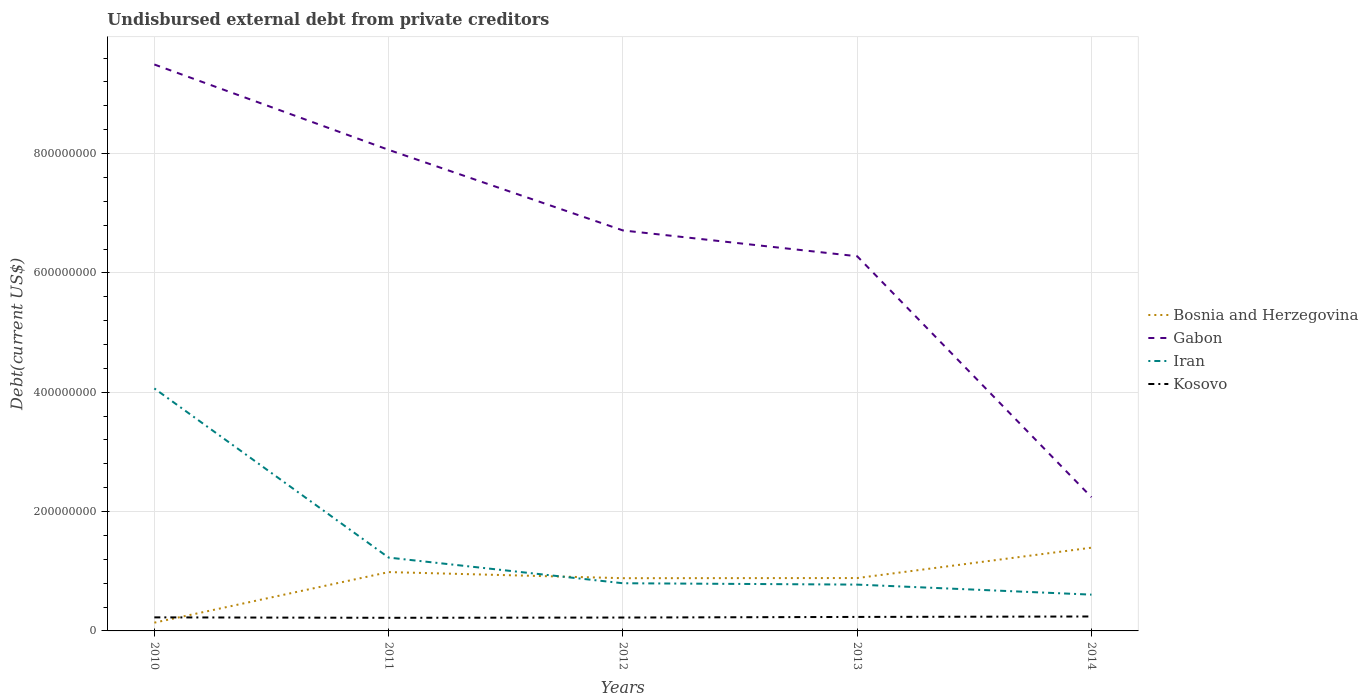How many different coloured lines are there?
Keep it short and to the point. 4. Is the number of lines equal to the number of legend labels?
Your answer should be compact. Yes. Across all years, what is the maximum total debt in Kosovo?
Your answer should be compact. 2.20e+07. What is the total total debt in Bosnia and Herzegovina in the graph?
Your answer should be compact. -4.09e+07. What is the difference between the highest and the second highest total debt in Iran?
Ensure brevity in your answer.  3.46e+08. What is the difference between the highest and the lowest total debt in Kosovo?
Ensure brevity in your answer.  2. Is the total debt in Bosnia and Herzegovina strictly greater than the total debt in Gabon over the years?
Your response must be concise. Yes. How many years are there in the graph?
Give a very brief answer. 5. What is the difference between two consecutive major ticks on the Y-axis?
Offer a terse response. 2.00e+08. Does the graph contain grids?
Provide a succinct answer. Yes. What is the title of the graph?
Your answer should be very brief. Undisbursed external debt from private creditors. Does "Peru" appear as one of the legend labels in the graph?
Provide a short and direct response. No. What is the label or title of the Y-axis?
Offer a very short reply. Debt(current US$). What is the Debt(current US$) of Bosnia and Herzegovina in 2010?
Provide a short and direct response. 1.38e+07. What is the Debt(current US$) in Gabon in 2010?
Provide a succinct answer. 9.49e+08. What is the Debt(current US$) of Iran in 2010?
Provide a succinct answer. 4.06e+08. What is the Debt(current US$) of Kosovo in 2010?
Offer a terse response. 2.27e+07. What is the Debt(current US$) of Bosnia and Herzegovina in 2011?
Offer a terse response. 9.86e+07. What is the Debt(current US$) in Gabon in 2011?
Provide a short and direct response. 8.06e+08. What is the Debt(current US$) of Iran in 2011?
Your answer should be compact. 1.23e+08. What is the Debt(current US$) of Kosovo in 2011?
Provide a succinct answer. 2.20e+07. What is the Debt(current US$) in Bosnia and Herzegovina in 2012?
Provide a succinct answer. 8.84e+07. What is the Debt(current US$) in Gabon in 2012?
Keep it short and to the point. 6.71e+08. What is the Debt(current US$) of Iran in 2012?
Your answer should be very brief. 7.99e+07. What is the Debt(current US$) in Kosovo in 2012?
Give a very brief answer. 2.24e+07. What is the Debt(current US$) in Bosnia and Herzegovina in 2013?
Your response must be concise. 8.86e+07. What is the Debt(current US$) in Gabon in 2013?
Offer a terse response. 6.28e+08. What is the Debt(current US$) of Iran in 2013?
Offer a terse response. 7.76e+07. What is the Debt(current US$) of Kosovo in 2013?
Offer a terse response. 2.34e+07. What is the Debt(current US$) in Bosnia and Herzegovina in 2014?
Give a very brief answer. 1.40e+08. What is the Debt(current US$) in Gabon in 2014?
Offer a terse response. 2.24e+08. What is the Debt(current US$) of Iran in 2014?
Keep it short and to the point. 6.08e+07. What is the Debt(current US$) of Kosovo in 2014?
Make the answer very short. 2.42e+07. Across all years, what is the maximum Debt(current US$) in Bosnia and Herzegovina?
Offer a terse response. 1.40e+08. Across all years, what is the maximum Debt(current US$) in Gabon?
Provide a short and direct response. 9.49e+08. Across all years, what is the maximum Debt(current US$) in Iran?
Offer a terse response. 4.06e+08. Across all years, what is the maximum Debt(current US$) in Kosovo?
Your answer should be compact. 2.42e+07. Across all years, what is the minimum Debt(current US$) of Bosnia and Herzegovina?
Give a very brief answer. 1.38e+07. Across all years, what is the minimum Debt(current US$) of Gabon?
Provide a succinct answer. 2.24e+08. Across all years, what is the minimum Debt(current US$) of Iran?
Keep it short and to the point. 6.08e+07. Across all years, what is the minimum Debt(current US$) in Kosovo?
Offer a very short reply. 2.20e+07. What is the total Debt(current US$) of Bosnia and Herzegovina in the graph?
Ensure brevity in your answer.  4.29e+08. What is the total Debt(current US$) in Gabon in the graph?
Your response must be concise. 3.28e+09. What is the total Debt(current US$) of Iran in the graph?
Your answer should be compact. 7.48e+08. What is the total Debt(current US$) of Kosovo in the graph?
Provide a short and direct response. 1.15e+08. What is the difference between the Debt(current US$) in Bosnia and Herzegovina in 2010 and that in 2011?
Provide a succinct answer. -8.48e+07. What is the difference between the Debt(current US$) of Gabon in 2010 and that in 2011?
Give a very brief answer. 1.43e+08. What is the difference between the Debt(current US$) of Iran in 2010 and that in 2011?
Your answer should be very brief. 2.83e+08. What is the difference between the Debt(current US$) of Kosovo in 2010 and that in 2011?
Provide a short and direct response. 7.19e+05. What is the difference between the Debt(current US$) in Bosnia and Herzegovina in 2010 and that in 2012?
Your response must be concise. -7.46e+07. What is the difference between the Debt(current US$) in Gabon in 2010 and that in 2012?
Offer a very short reply. 2.78e+08. What is the difference between the Debt(current US$) in Iran in 2010 and that in 2012?
Ensure brevity in your answer.  3.26e+08. What is the difference between the Debt(current US$) of Kosovo in 2010 and that in 2012?
Offer a very short reply. 2.85e+05. What is the difference between the Debt(current US$) in Bosnia and Herzegovina in 2010 and that in 2013?
Provide a short and direct response. -7.48e+07. What is the difference between the Debt(current US$) of Gabon in 2010 and that in 2013?
Keep it short and to the point. 3.21e+08. What is the difference between the Debt(current US$) of Iran in 2010 and that in 2013?
Your answer should be very brief. 3.29e+08. What is the difference between the Debt(current US$) of Kosovo in 2010 and that in 2013?
Your answer should be compact. -7.30e+05. What is the difference between the Debt(current US$) in Bosnia and Herzegovina in 2010 and that in 2014?
Offer a very short reply. -1.26e+08. What is the difference between the Debt(current US$) in Gabon in 2010 and that in 2014?
Make the answer very short. 7.25e+08. What is the difference between the Debt(current US$) in Iran in 2010 and that in 2014?
Keep it short and to the point. 3.46e+08. What is the difference between the Debt(current US$) of Kosovo in 2010 and that in 2014?
Provide a short and direct response. -1.48e+06. What is the difference between the Debt(current US$) in Bosnia and Herzegovina in 2011 and that in 2012?
Your response must be concise. 1.02e+07. What is the difference between the Debt(current US$) of Gabon in 2011 and that in 2012?
Keep it short and to the point. 1.35e+08. What is the difference between the Debt(current US$) in Iran in 2011 and that in 2012?
Keep it short and to the point. 4.30e+07. What is the difference between the Debt(current US$) of Kosovo in 2011 and that in 2012?
Give a very brief answer. -4.34e+05. What is the difference between the Debt(current US$) in Bosnia and Herzegovina in 2011 and that in 2013?
Provide a short and direct response. 1.00e+07. What is the difference between the Debt(current US$) of Gabon in 2011 and that in 2013?
Give a very brief answer. 1.78e+08. What is the difference between the Debt(current US$) of Iran in 2011 and that in 2013?
Make the answer very short. 4.53e+07. What is the difference between the Debt(current US$) in Kosovo in 2011 and that in 2013?
Provide a succinct answer. -1.45e+06. What is the difference between the Debt(current US$) of Bosnia and Herzegovina in 2011 and that in 2014?
Provide a succinct answer. -4.09e+07. What is the difference between the Debt(current US$) of Gabon in 2011 and that in 2014?
Make the answer very short. 5.82e+08. What is the difference between the Debt(current US$) in Iran in 2011 and that in 2014?
Your response must be concise. 6.21e+07. What is the difference between the Debt(current US$) in Kosovo in 2011 and that in 2014?
Your answer should be very brief. -2.20e+06. What is the difference between the Debt(current US$) in Bosnia and Herzegovina in 2012 and that in 2013?
Your answer should be compact. -2.22e+05. What is the difference between the Debt(current US$) in Gabon in 2012 and that in 2013?
Keep it short and to the point. 4.33e+07. What is the difference between the Debt(current US$) in Iran in 2012 and that in 2013?
Ensure brevity in your answer.  2.28e+06. What is the difference between the Debt(current US$) of Kosovo in 2012 and that in 2013?
Offer a very short reply. -1.02e+06. What is the difference between the Debt(current US$) in Bosnia and Herzegovina in 2012 and that in 2014?
Make the answer very short. -5.11e+07. What is the difference between the Debt(current US$) of Gabon in 2012 and that in 2014?
Ensure brevity in your answer.  4.47e+08. What is the difference between the Debt(current US$) in Iran in 2012 and that in 2014?
Make the answer very short. 1.91e+07. What is the difference between the Debt(current US$) of Kosovo in 2012 and that in 2014?
Offer a very short reply. -1.77e+06. What is the difference between the Debt(current US$) in Bosnia and Herzegovina in 2013 and that in 2014?
Your response must be concise. -5.09e+07. What is the difference between the Debt(current US$) of Gabon in 2013 and that in 2014?
Provide a succinct answer. 4.04e+08. What is the difference between the Debt(current US$) in Iran in 2013 and that in 2014?
Keep it short and to the point. 1.68e+07. What is the difference between the Debt(current US$) in Kosovo in 2013 and that in 2014?
Offer a very short reply. -7.54e+05. What is the difference between the Debt(current US$) of Bosnia and Herzegovina in 2010 and the Debt(current US$) of Gabon in 2011?
Offer a terse response. -7.92e+08. What is the difference between the Debt(current US$) of Bosnia and Herzegovina in 2010 and the Debt(current US$) of Iran in 2011?
Provide a succinct answer. -1.09e+08. What is the difference between the Debt(current US$) of Bosnia and Herzegovina in 2010 and the Debt(current US$) of Kosovo in 2011?
Your answer should be compact. -8.16e+06. What is the difference between the Debt(current US$) in Gabon in 2010 and the Debt(current US$) in Iran in 2011?
Keep it short and to the point. 8.26e+08. What is the difference between the Debt(current US$) of Gabon in 2010 and the Debt(current US$) of Kosovo in 2011?
Give a very brief answer. 9.27e+08. What is the difference between the Debt(current US$) of Iran in 2010 and the Debt(current US$) of Kosovo in 2011?
Offer a terse response. 3.84e+08. What is the difference between the Debt(current US$) in Bosnia and Herzegovina in 2010 and the Debt(current US$) in Gabon in 2012?
Provide a short and direct response. -6.57e+08. What is the difference between the Debt(current US$) in Bosnia and Herzegovina in 2010 and the Debt(current US$) in Iran in 2012?
Offer a terse response. -6.61e+07. What is the difference between the Debt(current US$) in Bosnia and Herzegovina in 2010 and the Debt(current US$) in Kosovo in 2012?
Ensure brevity in your answer.  -8.60e+06. What is the difference between the Debt(current US$) of Gabon in 2010 and the Debt(current US$) of Iran in 2012?
Your response must be concise. 8.69e+08. What is the difference between the Debt(current US$) of Gabon in 2010 and the Debt(current US$) of Kosovo in 2012?
Offer a terse response. 9.27e+08. What is the difference between the Debt(current US$) in Iran in 2010 and the Debt(current US$) in Kosovo in 2012?
Ensure brevity in your answer.  3.84e+08. What is the difference between the Debt(current US$) in Bosnia and Herzegovina in 2010 and the Debt(current US$) in Gabon in 2013?
Offer a terse response. -6.14e+08. What is the difference between the Debt(current US$) of Bosnia and Herzegovina in 2010 and the Debt(current US$) of Iran in 2013?
Offer a terse response. -6.38e+07. What is the difference between the Debt(current US$) of Bosnia and Herzegovina in 2010 and the Debt(current US$) of Kosovo in 2013?
Your answer should be very brief. -9.61e+06. What is the difference between the Debt(current US$) in Gabon in 2010 and the Debt(current US$) in Iran in 2013?
Make the answer very short. 8.72e+08. What is the difference between the Debt(current US$) in Gabon in 2010 and the Debt(current US$) in Kosovo in 2013?
Your response must be concise. 9.26e+08. What is the difference between the Debt(current US$) of Iran in 2010 and the Debt(current US$) of Kosovo in 2013?
Provide a succinct answer. 3.83e+08. What is the difference between the Debt(current US$) of Bosnia and Herzegovina in 2010 and the Debt(current US$) of Gabon in 2014?
Keep it short and to the point. -2.10e+08. What is the difference between the Debt(current US$) of Bosnia and Herzegovina in 2010 and the Debt(current US$) of Iran in 2014?
Your answer should be very brief. -4.70e+07. What is the difference between the Debt(current US$) of Bosnia and Herzegovina in 2010 and the Debt(current US$) of Kosovo in 2014?
Provide a succinct answer. -1.04e+07. What is the difference between the Debt(current US$) of Gabon in 2010 and the Debt(current US$) of Iran in 2014?
Provide a short and direct response. 8.89e+08. What is the difference between the Debt(current US$) in Gabon in 2010 and the Debt(current US$) in Kosovo in 2014?
Give a very brief answer. 9.25e+08. What is the difference between the Debt(current US$) of Iran in 2010 and the Debt(current US$) of Kosovo in 2014?
Offer a terse response. 3.82e+08. What is the difference between the Debt(current US$) in Bosnia and Herzegovina in 2011 and the Debt(current US$) in Gabon in 2012?
Give a very brief answer. -5.73e+08. What is the difference between the Debt(current US$) of Bosnia and Herzegovina in 2011 and the Debt(current US$) of Iran in 2012?
Give a very brief answer. 1.87e+07. What is the difference between the Debt(current US$) of Bosnia and Herzegovina in 2011 and the Debt(current US$) of Kosovo in 2012?
Provide a short and direct response. 7.62e+07. What is the difference between the Debt(current US$) in Gabon in 2011 and the Debt(current US$) in Iran in 2012?
Provide a short and direct response. 7.26e+08. What is the difference between the Debt(current US$) of Gabon in 2011 and the Debt(current US$) of Kosovo in 2012?
Keep it short and to the point. 7.84e+08. What is the difference between the Debt(current US$) of Iran in 2011 and the Debt(current US$) of Kosovo in 2012?
Your answer should be compact. 1.00e+08. What is the difference between the Debt(current US$) in Bosnia and Herzegovina in 2011 and the Debt(current US$) in Gabon in 2013?
Provide a succinct answer. -5.29e+08. What is the difference between the Debt(current US$) of Bosnia and Herzegovina in 2011 and the Debt(current US$) of Iran in 2013?
Keep it short and to the point. 2.10e+07. What is the difference between the Debt(current US$) in Bosnia and Herzegovina in 2011 and the Debt(current US$) in Kosovo in 2013?
Make the answer very short. 7.52e+07. What is the difference between the Debt(current US$) of Gabon in 2011 and the Debt(current US$) of Iran in 2013?
Your answer should be compact. 7.29e+08. What is the difference between the Debt(current US$) of Gabon in 2011 and the Debt(current US$) of Kosovo in 2013?
Make the answer very short. 7.83e+08. What is the difference between the Debt(current US$) in Iran in 2011 and the Debt(current US$) in Kosovo in 2013?
Your answer should be compact. 9.95e+07. What is the difference between the Debt(current US$) of Bosnia and Herzegovina in 2011 and the Debt(current US$) of Gabon in 2014?
Make the answer very short. -1.26e+08. What is the difference between the Debt(current US$) of Bosnia and Herzegovina in 2011 and the Debt(current US$) of Iran in 2014?
Offer a terse response. 3.78e+07. What is the difference between the Debt(current US$) of Bosnia and Herzegovina in 2011 and the Debt(current US$) of Kosovo in 2014?
Give a very brief answer. 7.44e+07. What is the difference between the Debt(current US$) of Gabon in 2011 and the Debt(current US$) of Iran in 2014?
Offer a terse response. 7.45e+08. What is the difference between the Debt(current US$) in Gabon in 2011 and the Debt(current US$) in Kosovo in 2014?
Your response must be concise. 7.82e+08. What is the difference between the Debt(current US$) in Iran in 2011 and the Debt(current US$) in Kosovo in 2014?
Provide a succinct answer. 9.87e+07. What is the difference between the Debt(current US$) in Bosnia and Herzegovina in 2012 and the Debt(current US$) in Gabon in 2013?
Your answer should be very brief. -5.40e+08. What is the difference between the Debt(current US$) in Bosnia and Herzegovina in 2012 and the Debt(current US$) in Iran in 2013?
Your answer should be compact. 1.08e+07. What is the difference between the Debt(current US$) in Bosnia and Herzegovina in 2012 and the Debt(current US$) in Kosovo in 2013?
Provide a succinct answer. 6.49e+07. What is the difference between the Debt(current US$) of Gabon in 2012 and the Debt(current US$) of Iran in 2013?
Make the answer very short. 5.94e+08. What is the difference between the Debt(current US$) in Gabon in 2012 and the Debt(current US$) in Kosovo in 2013?
Make the answer very short. 6.48e+08. What is the difference between the Debt(current US$) of Iran in 2012 and the Debt(current US$) of Kosovo in 2013?
Keep it short and to the point. 5.65e+07. What is the difference between the Debt(current US$) of Bosnia and Herzegovina in 2012 and the Debt(current US$) of Gabon in 2014?
Ensure brevity in your answer.  -1.36e+08. What is the difference between the Debt(current US$) of Bosnia and Herzegovina in 2012 and the Debt(current US$) of Iran in 2014?
Keep it short and to the point. 2.76e+07. What is the difference between the Debt(current US$) of Bosnia and Herzegovina in 2012 and the Debt(current US$) of Kosovo in 2014?
Ensure brevity in your answer.  6.42e+07. What is the difference between the Debt(current US$) in Gabon in 2012 and the Debt(current US$) in Iran in 2014?
Provide a short and direct response. 6.10e+08. What is the difference between the Debt(current US$) of Gabon in 2012 and the Debt(current US$) of Kosovo in 2014?
Provide a short and direct response. 6.47e+08. What is the difference between the Debt(current US$) in Iran in 2012 and the Debt(current US$) in Kosovo in 2014?
Ensure brevity in your answer.  5.57e+07. What is the difference between the Debt(current US$) in Bosnia and Herzegovina in 2013 and the Debt(current US$) in Gabon in 2014?
Offer a terse response. -1.36e+08. What is the difference between the Debt(current US$) of Bosnia and Herzegovina in 2013 and the Debt(current US$) of Iran in 2014?
Offer a very short reply. 2.78e+07. What is the difference between the Debt(current US$) of Bosnia and Herzegovina in 2013 and the Debt(current US$) of Kosovo in 2014?
Your answer should be very brief. 6.44e+07. What is the difference between the Debt(current US$) in Gabon in 2013 and the Debt(current US$) in Iran in 2014?
Offer a terse response. 5.67e+08. What is the difference between the Debt(current US$) in Gabon in 2013 and the Debt(current US$) in Kosovo in 2014?
Make the answer very short. 6.04e+08. What is the difference between the Debt(current US$) in Iran in 2013 and the Debt(current US$) in Kosovo in 2014?
Your answer should be very brief. 5.34e+07. What is the average Debt(current US$) in Bosnia and Herzegovina per year?
Give a very brief answer. 8.58e+07. What is the average Debt(current US$) of Gabon per year?
Provide a succinct answer. 6.56e+08. What is the average Debt(current US$) of Iran per year?
Make the answer very short. 1.50e+08. What is the average Debt(current US$) of Kosovo per year?
Your answer should be very brief. 2.30e+07. In the year 2010, what is the difference between the Debt(current US$) of Bosnia and Herzegovina and Debt(current US$) of Gabon?
Keep it short and to the point. -9.35e+08. In the year 2010, what is the difference between the Debt(current US$) of Bosnia and Herzegovina and Debt(current US$) of Iran?
Offer a very short reply. -3.93e+08. In the year 2010, what is the difference between the Debt(current US$) of Bosnia and Herzegovina and Debt(current US$) of Kosovo?
Your answer should be very brief. -8.88e+06. In the year 2010, what is the difference between the Debt(current US$) in Gabon and Debt(current US$) in Iran?
Give a very brief answer. 5.43e+08. In the year 2010, what is the difference between the Debt(current US$) in Gabon and Debt(current US$) in Kosovo?
Offer a very short reply. 9.27e+08. In the year 2010, what is the difference between the Debt(current US$) of Iran and Debt(current US$) of Kosovo?
Provide a short and direct response. 3.84e+08. In the year 2011, what is the difference between the Debt(current US$) of Bosnia and Herzegovina and Debt(current US$) of Gabon?
Provide a short and direct response. -7.08e+08. In the year 2011, what is the difference between the Debt(current US$) in Bosnia and Herzegovina and Debt(current US$) in Iran?
Your answer should be compact. -2.43e+07. In the year 2011, what is the difference between the Debt(current US$) of Bosnia and Herzegovina and Debt(current US$) of Kosovo?
Make the answer very short. 7.66e+07. In the year 2011, what is the difference between the Debt(current US$) of Gabon and Debt(current US$) of Iran?
Make the answer very short. 6.83e+08. In the year 2011, what is the difference between the Debt(current US$) of Gabon and Debt(current US$) of Kosovo?
Your answer should be very brief. 7.84e+08. In the year 2011, what is the difference between the Debt(current US$) in Iran and Debt(current US$) in Kosovo?
Make the answer very short. 1.01e+08. In the year 2012, what is the difference between the Debt(current US$) of Bosnia and Herzegovina and Debt(current US$) of Gabon?
Your answer should be compact. -5.83e+08. In the year 2012, what is the difference between the Debt(current US$) in Bosnia and Herzegovina and Debt(current US$) in Iran?
Your answer should be very brief. 8.48e+06. In the year 2012, what is the difference between the Debt(current US$) in Bosnia and Herzegovina and Debt(current US$) in Kosovo?
Offer a very short reply. 6.60e+07. In the year 2012, what is the difference between the Debt(current US$) of Gabon and Debt(current US$) of Iran?
Provide a succinct answer. 5.91e+08. In the year 2012, what is the difference between the Debt(current US$) of Gabon and Debt(current US$) of Kosovo?
Offer a very short reply. 6.49e+08. In the year 2012, what is the difference between the Debt(current US$) of Iran and Debt(current US$) of Kosovo?
Provide a succinct answer. 5.75e+07. In the year 2013, what is the difference between the Debt(current US$) of Bosnia and Herzegovina and Debt(current US$) of Gabon?
Offer a terse response. -5.39e+08. In the year 2013, what is the difference between the Debt(current US$) of Bosnia and Herzegovina and Debt(current US$) of Iran?
Your answer should be compact. 1.10e+07. In the year 2013, what is the difference between the Debt(current US$) of Bosnia and Herzegovina and Debt(current US$) of Kosovo?
Provide a succinct answer. 6.52e+07. In the year 2013, what is the difference between the Debt(current US$) of Gabon and Debt(current US$) of Iran?
Ensure brevity in your answer.  5.50e+08. In the year 2013, what is the difference between the Debt(current US$) of Gabon and Debt(current US$) of Kosovo?
Your answer should be very brief. 6.04e+08. In the year 2013, what is the difference between the Debt(current US$) of Iran and Debt(current US$) of Kosovo?
Your answer should be compact. 5.42e+07. In the year 2014, what is the difference between the Debt(current US$) in Bosnia and Herzegovina and Debt(current US$) in Gabon?
Provide a succinct answer. -8.46e+07. In the year 2014, what is the difference between the Debt(current US$) in Bosnia and Herzegovina and Debt(current US$) in Iran?
Give a very brief answer. 7.87e+07. In the year 2014, what is the difference between the Debt(current US$) in Bosnia and Herzegovina and Debt(current US$) in Kosovo?
Offer a terse response. 1.15e+08. In the year 2014, what is the difference between the Debt(current US$) of Gabon and Debt(current US$) of Iran?
Give a very brief answer. 1.63e+08. In the year 2014, what is the difference between the Debt(current US$) of Gabon and Debt(current US$) of Kosovo?
Offer a terse response. 2.00e+08. In the year 2014, what is the difference between the Debt(current US$) in Iran and Debt(current US$) in Kosovo?
Keep it short and to the point. 3.66e+07. What is the ratio of the Debt(current US$) in Bosnia and Herzegovina in 2010 to that in 2011?
Your answer should be compact. 0.14. What is the ratio of the Debt(current US$) in Gabon in 2010 to that in 2011?
Your answer should be very brief. 1.18. What is the ratio of the Debt(current US$) of Iran in 2010 to that in 2011?
Make the answer very short. 3.31. What is the ratio of the Debt(current US$) in Kosovo in 2010 to that in 2011?
Ensure brevity in your answer.  1.03. What is the ratio of the Debt(current US$) in Bosnia and Herzegovina in 2010 to that in 2012?
Give a very brief answer. 0.16. What is the ratio of the Debt(current US$) in Gabon in 2010 to that in 2012?
Provide a succinct answer. 1.41. What is the ratio of the Debt(current US$) of Iran in 2010 to that in 2012?
Give a very brief answer. 5.09. What is the ratio of the Debt(current US$) in Kosovo in 2010 to that in 2012?
Offer a very short reply. 1.01. What is the ratio of the Debt(current US$) in Bosnia and Herzegovina in 2010 to that in 2013?
Ensure brevity in your answer.  0.16. What is the ratio of the Debt(current US$) of Gabon in 2010 to that in 2013?
Your answer should be compact. 1.51. What is the ratio of the Debt(current US$) in Iran in 2010 to that in 2013?
Keep it short and to the point. 5.24. What is the ratio of the Debt(current US$) of Kosovo in 2010 to that in 2013?
Keep it short and to the point. 0.97. What is the ratio of the Debt(current US$) in Bosnia and Herzegovina in 2010 to that in 2014?
Make the answer very short. 0.1. What is the ratio of the Debt(current US$) in Gabon in 2010 to that in 2014?
Offer a terse response. 4.24. What is the ratio of the Debt(current US$) in Iran in 2010 to that in 2014?
Your answer should be very brief. 6.68. What is the ratio of the Debt(current US$) of Kosovo in 2010 to that in 2014?
Ensure brevity in your answer.  0.94. What is the ratio of the Debt(current US$) of Bosnia and Herzegovina in 2011 to that in 2012?
Your answer should be compact. 1.12. What is the ratio of the Debt(current US$) of Gabon in 2011 to that in 2012?
Your answer should be very brief. 1.2. What is the ratio of the Debt(current US$) in Iran in 2011 to that in 2012?
Your answer should be compact. 1.54. What is the ratio of the Debt(current US$) of Kosovo in 2011 to that in 2012?
Your answer should be very brief. 0.98. What is the ratio of the Debt(current US$) in Bosnia and Herzegovina in 2011 to that in 2013?
Give a very brief answer. 1.11. What is the ratio of the Debt(current US$) in Gabon in 2011 to that in 2013?
Offer a terse response. 1.28. What is the ratio of the Debt(current US$) of Iran in 2011 to that in 2013?
Provide a succinct answer. 1.58. What is the ratio of the Debt(current US$) in Kosovo in 2011 to that in 2013?
Make the answer very short. 0.94. What is the ratio of the Debt(current US$) of Bosnia and Herzegovina in 2011 to that in 2014?
Your answer should be very brief. 0.71. What is the ratio of the Debt(current US$) in Gabon in 2011 to that in 2014?
Give a very brief answer. 3.6. What is the ratio of the Debt(current US$) of Iran in 2011 to that in 2014?
Your response must be concise. 2.02. What is the ratio of the Debt(current US$) in Kosovo in 2011 to that in 2014?
Your response must be concise. 0.91. What is the ratio of the Debt(current US$) of Gabon in 2012 to that in 2013?
Offer a terse response. 1.07. What is the ratio of the Debt(current US$) in Iran in 2012 to that in 2013?
Make the answer very short. 1.03. What is the ratio of the Debt(current US$) of Kosovo in 2012 to that in 2013?
Your response must be concise. 0.96. What is the ratio of the Debt(current US$) in Bosnia and Herzegovina in 2012 to that in 2014?
Your answer should be very brief. 0.63. What is the ratio of the Debt(current US$) in Gabon in 2012 to that in 2014?
Keep it short and to the point. 2.99. What is the ratio of the Debt(current US$) in Iran in 2012 to that in 2014?
Make the answer very short. 1.31. What is the ratio of the Debt(current US$) in Kosovo in 2012 to that in 2014?
Provide a short and direct response. 0.93. What is the ratio of the Debt(current US$) of Bosnia and Herzegovina in 2013 to that in 2014?
Give a very brief answer. 0.64. What is the ratio of the Debt(current US$) of Gabon in 2013 to that in 2014?
Provide a short and direct response. 2.8. What is the ratio of the Debt(current US$) of Iran in 2013 to that in 2014?
Your answer should be very brief. 1.28. What is the ratio of the Debt(current US$) in Kosovo in 2013 to that in 2014?
Provide a succinct answer. 0.97. What is the difference between the highest and the second highest Debt(current US$) of Bosnia and Herzegovina?
Offer a terse response. 4.09e+07. What is the difference between the highest and the second highest Debt(current US$) in Gabon?
Ensure brevity in your answer.  1.43e+08. What is the difference between the highest and the second highest Debt(current US$) of Iran?
Provide a succinct answer. 2.83e+08. What is the difference between the highest and the second highest Debt(current US$) of Kosovo?
Provide a short and direct response. 7.54e+05. What is the difference between the highest and the lowest Debt(current US$) of Bosnia and Herzegovina?
Make the answer very short. 1.26e+08. What is the difference between the highest and the lowest Debt(current US$) in Gabon?
Offer a terse response. 7.25e+08. What is the difference between the highest and the lowest Debt(current US$) in Iran?
Ensure brevity in your answer.  3.46e+08. What is the difference between the highest and the lowest Debt(current US$) in Kosovo?
Provide a short and direct response. 2.20e+06. 